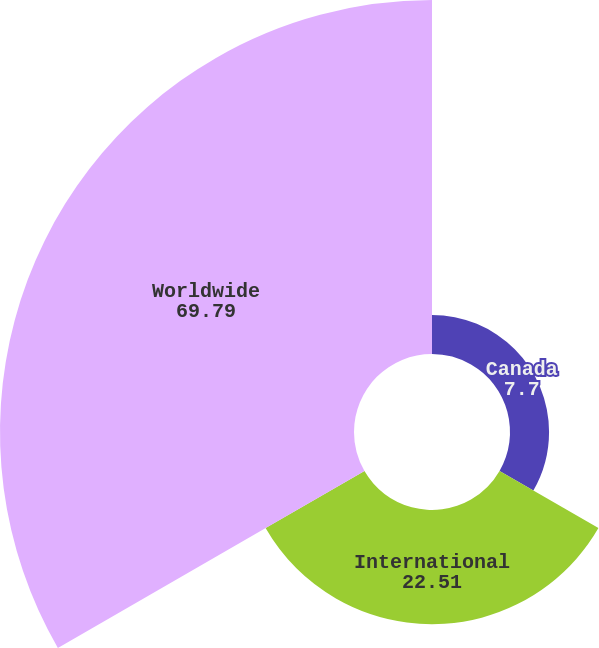Convert chart. <chart><loc_0><loc_0><loc_500><loc_500><pie_chart><fcel>Canada<fcel>International<fcel>Worldwide<nl><fcel>7.7%<fcel>22.51%<fcel>69.79%<nl></chart> 